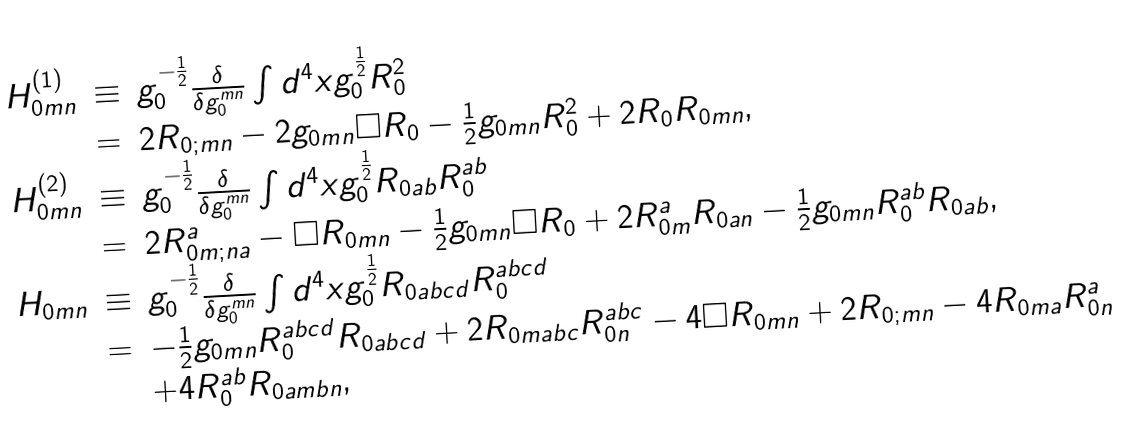<formula> <loc_0><loc_0><loc_500><loc_500>\begin{array} { c c l } H ^ { ( 1 ) } _ { 0 m n } & \equiv & g ^ { - \frac { 1 } { 2 } } _ { 0 } \frac { \delta } { \delta g ^ { m n } _ { 0 } } \int d ^ { 4 } x g ^ { \frac { 1 } { 2 } } _ { 0 } R ^ { 2 } _ { 0 } \\ & = & 2 R _ { 0 ; m n } - 2 g _ { 0 m n } \square R _ { 0 } - \frac { 1 } { 2 } g _ { 0 m n } R ^ { 2 } _ { 0 } + 2 R _ { 0 } R _ { 0 m n } , \\ H ^ { ( 2 ) } _ { 0 m n } & \equiv & g ^ { - \frac { 1 } { 2 } } _ { 0 } \frac { \delta } { \delta g ^ { m n } _ { 0 } } \int d ^ { 4 } x g ^ { \frac { 1 } { 2 } } _ { 0 } R _ { 0 a b } R ^ { a b } _ { 0 } \\ & = & 2 R ^ { a } _ { 0 m ; n a } - \square R _ { 0 m n } - \frac { 1 } { 2 } g _ { 0 m n } \square R _ { 0 } + 2 R ^ { a } _ { 0 m } R _ { 0 a n } - \frac { 1 } { 2 } g _ { 0 m n } R ^ { a b } _ { 0 } R _ { 0 a b } , \\ H _ { 0 m n } & \equiv & g ^ { - \frac { 1 } { 2 } } _ { 0 } \frac { \delta } { \delta g ^ { m n } _ { 0 } } \int d ^ { 4 } x g ^ { \frac { 1 } { 2 } } _ { 0 } R _ { 0 a b c d } R ^ { a b c d } _ { 0 } \\ & = & - \frac { 1 } { 2 } g _ { 0 m n } R ^ { a b c d } _ { 0 } R _ { 0 a b c d } + 2 R _ { 0 m a b c } R ^ { a b c } _ { 0 n } - 4 \square R _ { 0 m n } + 2 R _ { 0 ; m n } - 4 R _ { 0 m a } R ^ { a } _ { 0 n } \\ & & + 4 R ^ { a b } _ { 0 } R _ { 0 a m b n } , \end{array}</formula> 